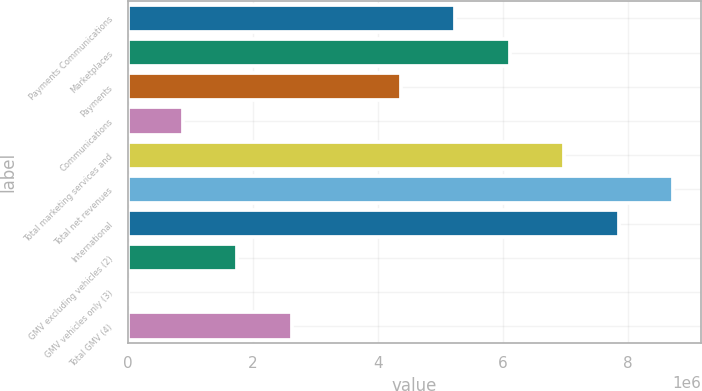Convert chart to OTSL. <chart><loc_0><loc_0><loc_500><loc_500><bar_chart><fcel>Payments Communications<fcel>Marketplaces<fcel>Payments<fcel>Communications<fcel>Total marketing services and<fcel>Total net revenues<fcel>International<fcel>GMV excluding vehicles (2)<fcel>GMV vehicles only (3)<fcel>Total GMV (4)<nl><fcel>5.23996e+06<fcel>6.11181e+06<fcel>4.36811e+06<fcel>880704<fcel>6.98366e+06<fcel>8.72736e+06<fcel>7.85551e+06<fcel>1.75255e+06<fcel>8853<fcel>2.62441e+06<nl></chart> 